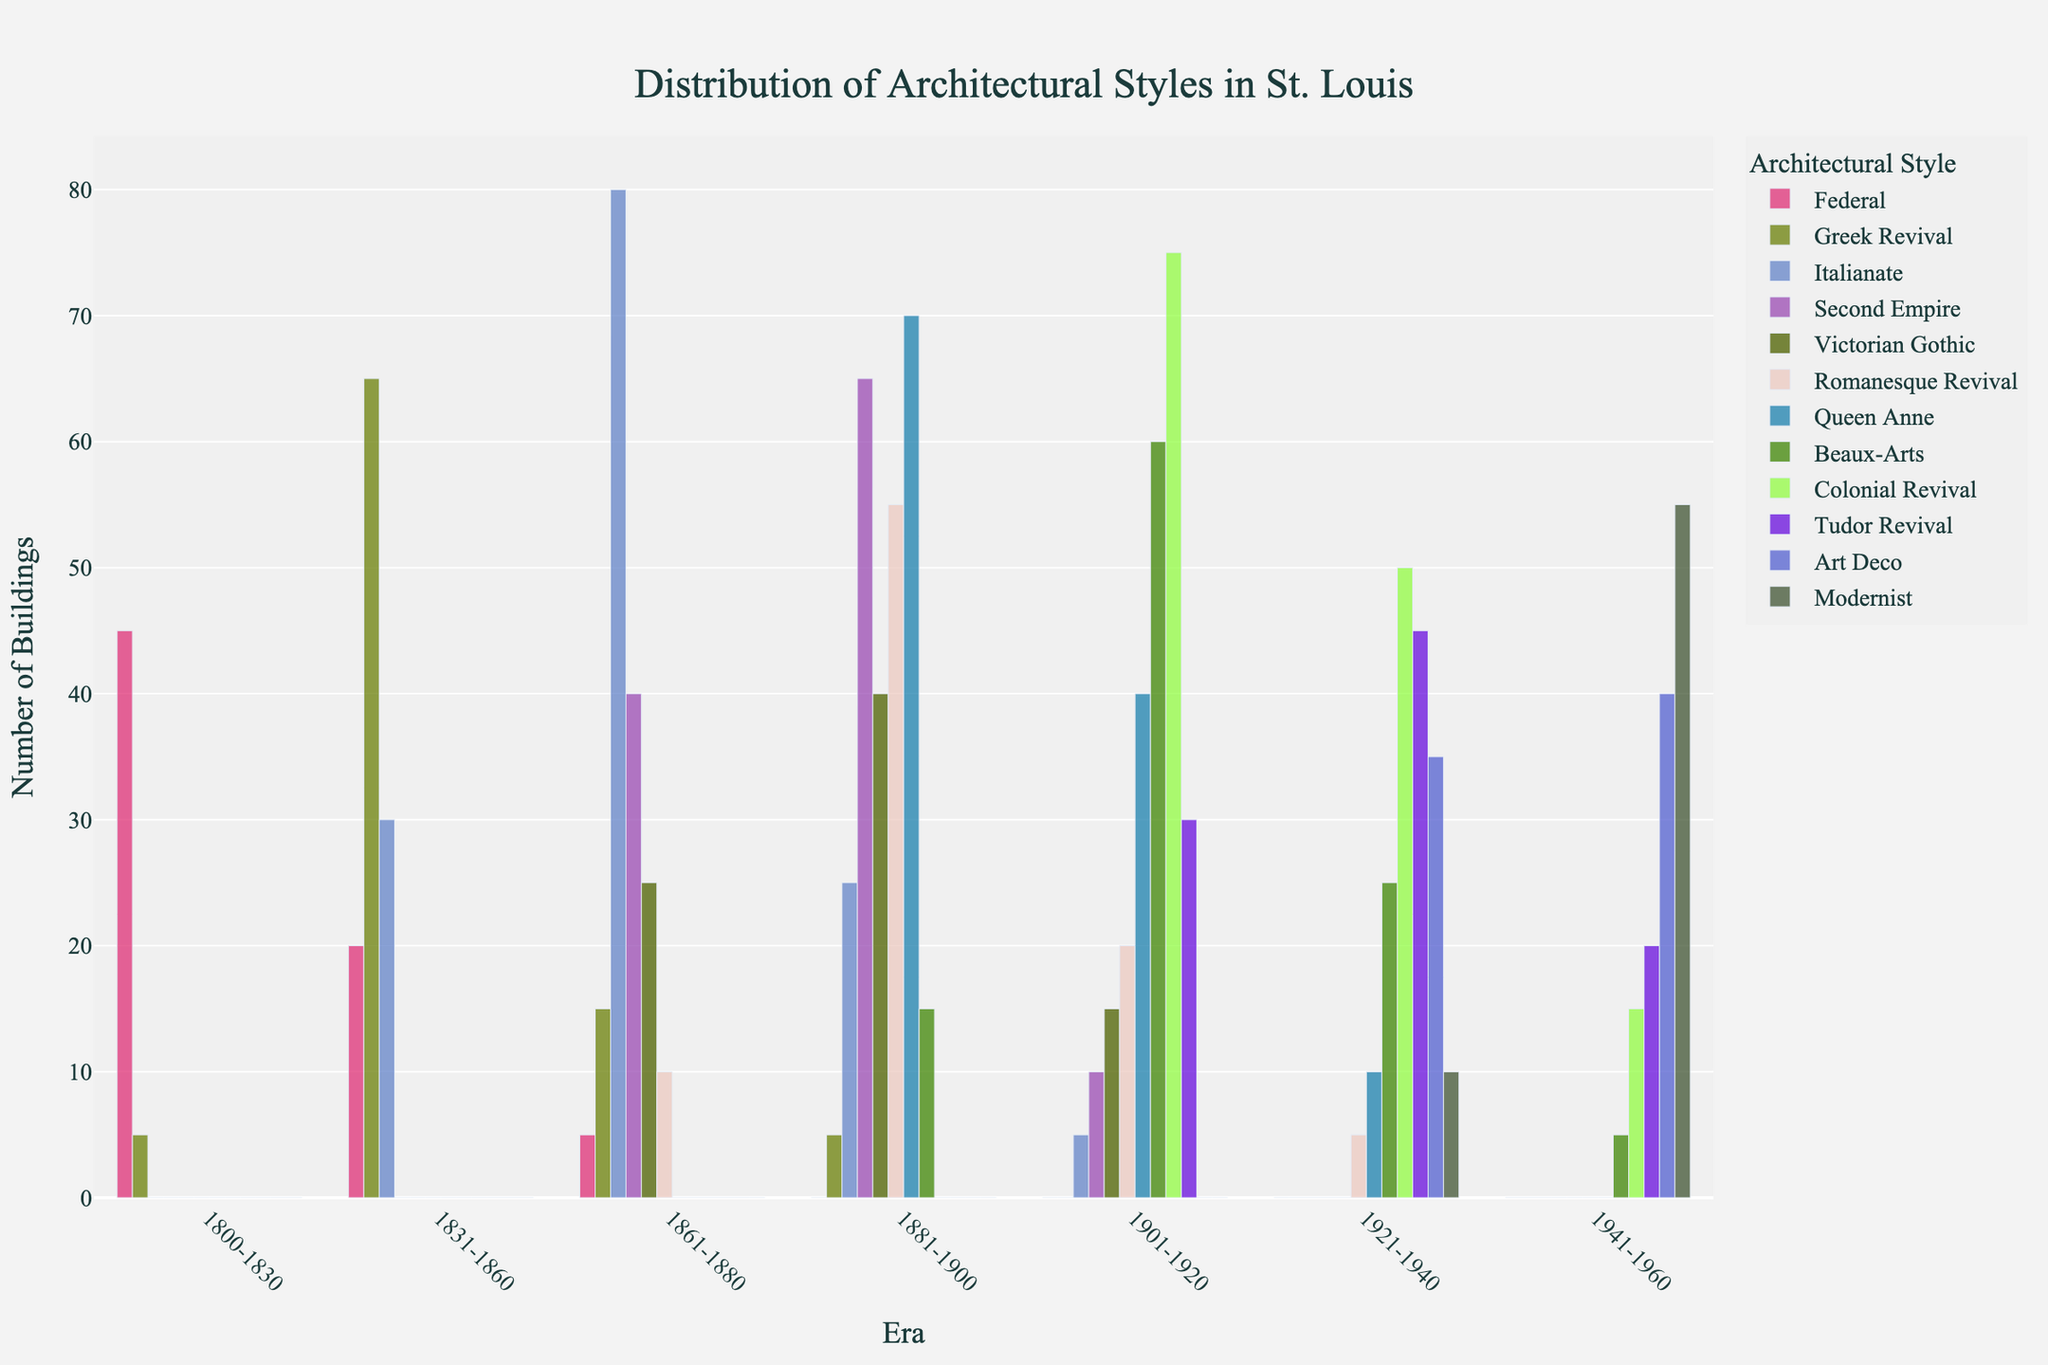Which era has the highest number of Queen Anne style buildings? From the visual representation, the era 1881-1900 shows the highest bar for Queen Anne style buildings.
Answer: 1881-1900 How many Federal style buildings were constructed in the era 1800-1830? The bar for Federal style in the era 1800-1830 has a value of 45, which can be directly read off the plot.
Answer: 45 Is there any era where Second Empire style is the most predominant? Yes, in the era 1881-1900, the bar for Second Empire style is the highest among all other styles in the same era.
Answer: 1881-1900 What is the total number of buildings from the eras 1941-1960 and 1921-1940 in the Art Deco style? The heights of the bars for Art Deco in the eras 1941-1960 and 1921-1940 are 40 and 35, respectively. Adding these together gives 40 + 35 = 75.
Answer: 75 Which architectural style was introduced latest according to the figure? The Modernist style appears only in the era 1941-1960, indicating it was introduced latest among the listed styles.
Answer: Modernist How does the number of Romanesque Revival buildings in the era 1881-1900 compare to the era 1831-1860? The era 1881-1900 shows a bar for Romanesque Revival with a height of 55, whereas the era 1831-1860 shows no bar, indicating zero buildings.
Answer: 1881-1900 is more In which era do Tudor Revival buildings first appear? Tudor Revival buildings first appear in the era 1901-1920, as indicated by the earliest bar.
Answer: 1901-1920 What is the total number of Victorian Gothic buildings constructed in the eras 1861-1880 and 1881-1900? Combining the numbers from the bars in these eras, 25 (1861-1880) and 40 (1881-1900), gives us a total of 25 + 40 = 65.
Answer: 65 Are there more Beaux-Arts buildings or Colonial Revival buildings in the era 1901-1920? The Beaux-Arts buildings have a bar height of 60, while Colonial Revival has 75 for the same era. Therefore, there are more Colonial Revival buildings.
Answer: Colonial Revival What is the average number of Greek Revival buildings across all eras? The number of Greek Revival buildings in each era is 5, 65, 15, 5, 0, 0, 0. Summing these gives 90 and the total number of eras is 7, so the average is 90/7 ≈ 12.86.
Answer: 12.86 